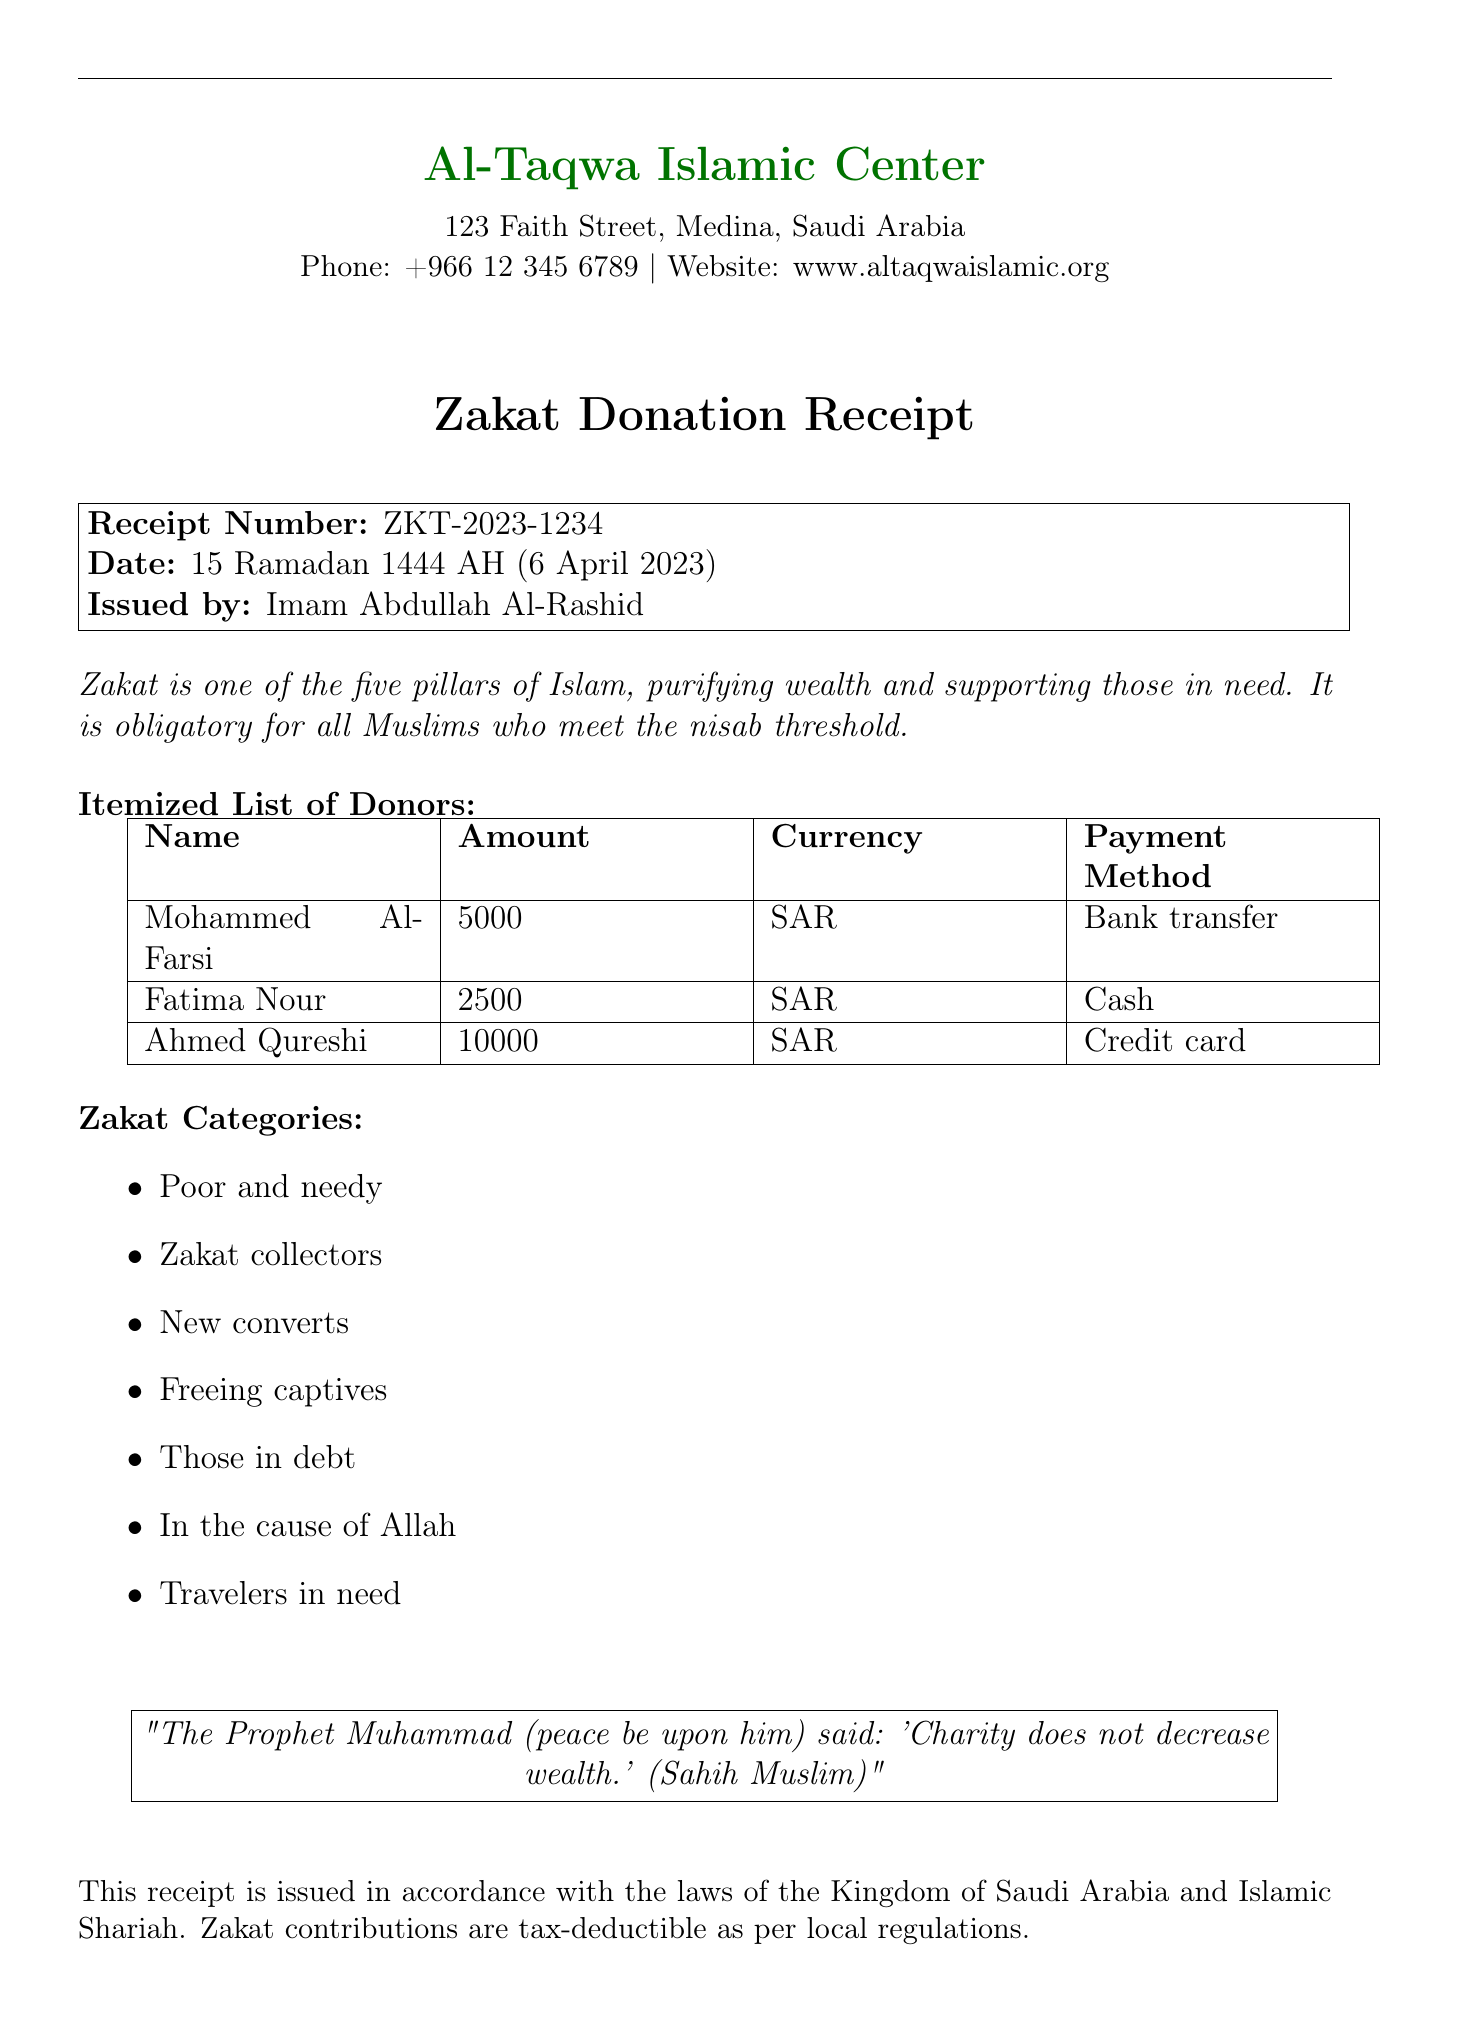What is the name of the mosque? The name of the mosque is provided in the header of the document.
Answer: Al-Taqwa Islamic Center What is the receipt number? The receipt number is specified in the receipt details section.
Answer: ZKT-2023-1234 Who issued the receipt? The issuer is named in the receipt details section.
Answer: Imam Abdullah Al-Rashid What is the total amount donated by Ahmed Qureshi? The donation amount for Ahmed Qureshi is listed in the itemized list of donors.
Answer: 10000 SAR What date was the receipt issued? The date of issuance is included in the receipt details section.
Answer: 15 Ramadan 1444 AH (6 April 2023) How many categories of zakat are mentioned? The document lists zakat categories, and the total can be counted from that list.
Answer: 7 categories What does the document state about tax deductions? The legal statement mentions the tax applicability related to zakat contributions.
Answer: Tax-deductible What payment method did Fatima Nour use? The payment method for Fatima Nour is specified in the donor list.
Answer: Cash What quote from the Prophet Muhammad is included? The document contains a specific quote regarding charity and its impact on wealth.
Answer: "Charity does not decrease wealth." 